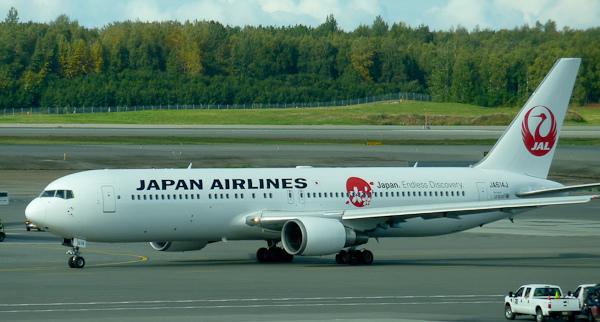What is written on the plane?
Concise answer only. Japan airlines. Is the logo like a crane?
Be succinct. Yes. What color is the plane's tail?
Keep it brief. White and red. What country does this plane go to?
Give a very brief answer. Japan. What image is on the tail of the plane?
Answer briefly. Bird. What word is on this plane?
Answer briefly. Japan airlines. Is this a two passenger plane?
Short answer required. No. 